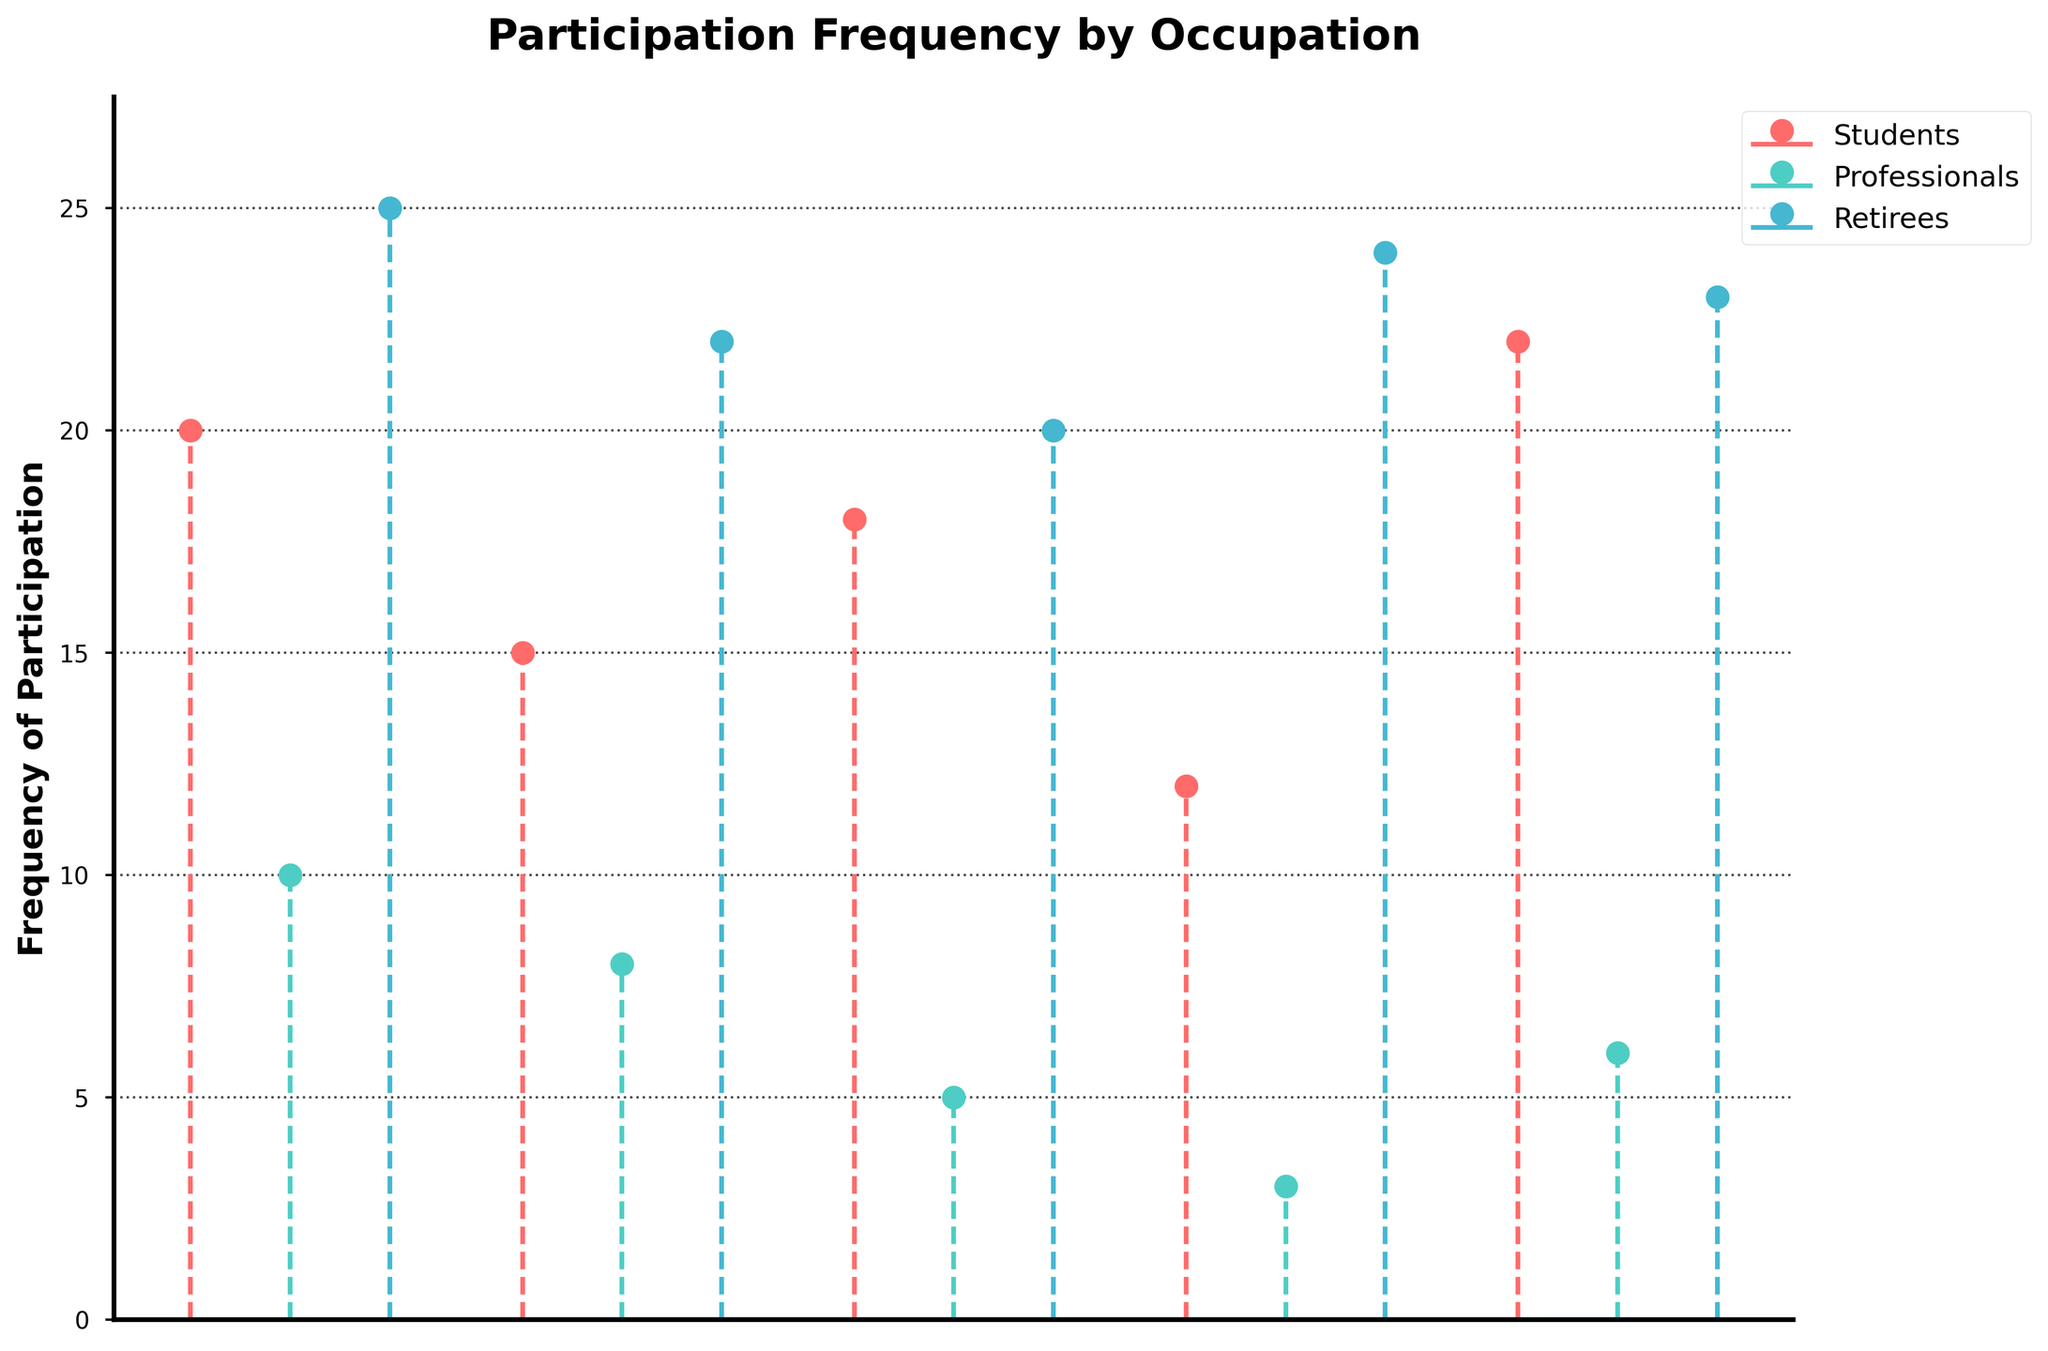What is the title of the figure? The title of the figure is displayed at the top of the plot as 'Participation Frequency by Occupation'.
Answer: Participation Frequency by Occupation Which occupation group has the highest participation frequency in the plot? The retirees group has the highest participation frequencies as indicated by the data points being the highest on the y-axis.
Answer: Retirees What is the average frequency of participation for students? To find the average frequency of participation for students, sum the students' data points (20, 15, 18, 12, 22) and divide by the number of data points: (20 + 15 + 18 + 12 + 22) / 5 = 87 / 5 = 17.4
Answer: 17.4 Which occupation group has the least variability in their participation frequency? Variability can be interpreted through the range of data points. Retirees have data points clustered closely together (20, 22, 25, 24, 23), indicating less variability compared to other groups.
Answer: Retirees How many participation data points are there for professionals? Count the number of stems for professionals which is 5.
Answer: 5 What is the range of the frequency values for retirees? The range for retirees is calculated by subtracting the minimum value from the maximum value: 25 - 20 = 5.
Answer: 5 Which occupation group has the lowest single participation frequency, and what is that frequency? Professionals have the lowest single participation frequency, indicated by the value 3 on the y-axis.
Answer: Professionals, 3 How does the participation frequency of the first data point for students compare to the maximum participation frequency for professionals? The first data point for students is 20, and the maximum for professionals is 10. 20 is greater than 10.
Answer: Students' first data point is higher What is the distribution shape of participation frequency data for retirees? The distribution of participation frequency for retirees is approximately uniform as the data points are close together and evenly spaced.
Answer: Approximately uniform What color represents the professionals' data points? Professionals' data points are represented in green color.
Answer: Green 